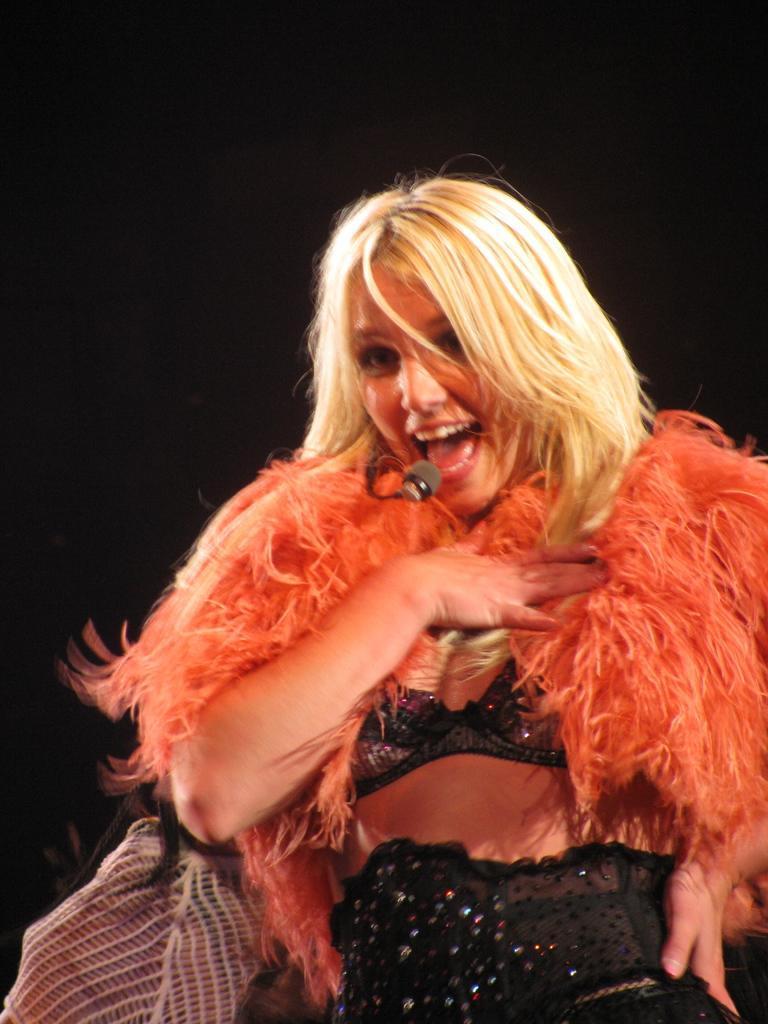Describe this image in one or two sentences. In this picture I can see a woman singing with the help of a microphone and I can see a dark background. 